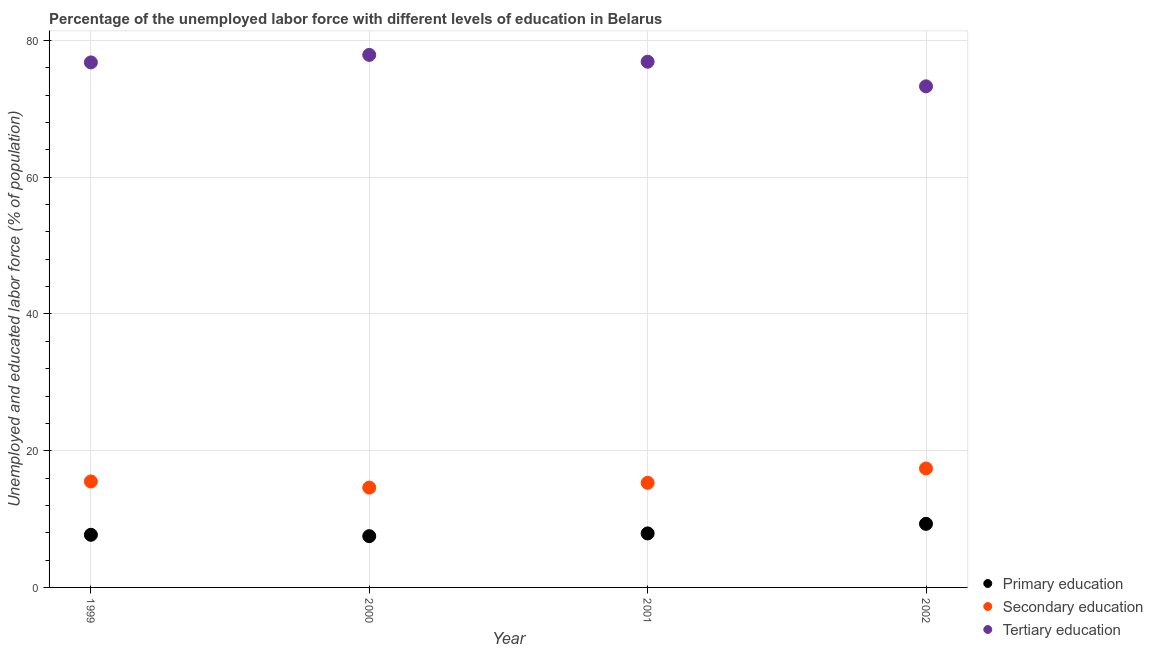Is the number of dotlines equal to the number of legend labels?
Offer a very short reply. Yes. What is the percentage of labor force who received primary education in 1999?
Give a very brief answer. 7.7. Across all years, what is the maximum percentage of labor force who received secondary education?
Keep it short and to the point. 17.4. Across all years, what is the minimum percentage of labor force who received tertiary education?
Keep it short and to the point. 73.3. In which year was the percentage of labor force who received primary education maximum?
Make the answer very short. 2002. In which year was the percentage of labor force who received secondary education minimum?
Provide a succinct answer. 2000. What is the total percentage of labor force who received tertiary education in the graph?
Ensure brevity in your answer.  304.9. What is the difference between the percentage of labor force who received primary education in 1999 and the percentage of labor force who received tertiary education in 2002?
Offer a very short reply. -65.6. What is the average percentage of labor force who received primary education per year?
Give a very brief answer. 8.1. In the year 2000, what is the difference between the percentage of labor force who received primary education and percentage of labor force who received tertiary education?
Your answer should be compact. -70.4. What is the ratio of the percentage of labor force who received tertiary education in 1999 to that in 2000?
Provide a short and direct response. 0.99. Is the percentage of labor force who received primary education in 2001 less than that in 2002?
Offer a very short reply. Yes. What is the difference between the highest and the second highest percentage of labor force who received tertiary education?
Your answer should be very brief. 1. What is the difference between the highest and the lowest percentage of labor force who received primary education?
Your answer should be compact. 1.8. In how many years, is the percentage of labor force who received primary education greater than the average percentage of labor force who received primary education taken over all years?
Make the answer very short. 1. What is the difference between two consecutive major ticks on the Y-axis?
Your answer should be very brief. 20. Does the graph contain any zero values?
Keep it short and to the point. No. Does the graph contain grids?
Offer a terse response. Yes. Where does the legend appear in the graph?
Ensure brevity in your answer.  Bottom right. What is the title of the graph?
Ensure brevity in your answer.  Percentage of the unemployed labor force with different levels of education in Belarus. What is the label or title of the Y-axis?
Offer a terse response. Unemployed and educated labor force (% of population). What is the Unemployed and educated labor force (% of population) of Primary education in 1999?
Make the answer very short. 7.7. What is the Unemployed and educated labor force (% of population) of Tertiary education in 1999?
Provide a succinct answer. 76.8. What is the Unemployed and educated labor force (% of population) in Primary education in 2000?
Offer a very short reply. 7.5. What is the Unemployed and educated labor force (% of population) in Secondary education in 2000?
Offer a very short reply. 14.6. What is the Unemployed and educated labor force (% of population) in Tertiary education in 2000?
Make the answer very short. 77.9. What is the Unemployed and educated labor force (% of population) in Primary education in 2001?
Your answer should be very brief. 7.9. What is the Unemployed and educated labor force (% of population) of Secondary education in 2001?
Give a very brief answer. 15.3. What is the Unemployed and educated labor force (% of population) in Tertiary education in 2001?
Give a very brief answer. 76.9. What is the Unemployed and educated labor force (% of population) of Primary education in 2002?
Keep it short and to the point. 9.3. What is the Unemployed and educated labor force (% of population) of Secondary education in 2002?
Ensure brevity in your answer.  17.4. What is the Unemployed and educated labor force (% of population) in Tertiary education in 2002?
Keep it short and to the point. 73.3. Across all years, what is the maximum Unemployed and educated labor force (% of population) in Primary education?
Your answer should be very brief. 9.3. Across all years, what is the maximum Unemployed and educated labor force (% of population) of Secondary education?
Your answer should be compact. 17.4. Across all years, what is the maximum Unemployed and educated labor force (% of population) of Tertiary education?
Provide a short and direct response. 77.9. Across all years, what is the minimum Unemployed and educated labor force (% of population) of Primary education?
Make the answer very short. 7.5. Across all years, what is the minimum Unemployed and educated labor force (% of population) in Secondary education?
Make the answer very short. 14.6. Across all years, what is the minimum Unemployed and educated labor force (% of population) in Tertiary education?
Give a very brief answer. 73.3. What is the total Unemployed and educated labor force (% of population) of Primary education in the graph?
Provide a succinct answer. 32.4. What is the total Unemployed and educated labor force (% of population) of Secondary education in the graph?
Give a very brief answer. 62.8. What is the total Unemployed and educated labor force (% of population) of Tertiary education in the graph?
Make the answer very short. 304.9. What is the difference between the Unemployed and educated labor force (% of population) in Primary education in 1999 and that in 2001?
Provide a short and direct response. -0.2. What is the difference between the Unemployed and educated labor force (% of population) of Secondary education in 1999 and that in 2001?
Ensure brevity in your answer.  0.2. What is the difference between the Unemployed and educated labor force (% of population) of Tertiary education in 1999 and that in 2001?
Offer a very short reply. -0.1. What is the difference between the Unemployed and educated labor force (% of population) in Tertiary education in 1999 and that in 2002?
Your answer should be very brief. 3.5. What is the difference between the Unemployed and educated labor force (% of population) in Primary education in 2000 and that in 2001?
Ensure brevity in your answer.  -0.4. What is the difference between the Unemployed and educated labor force (% of population) in Secondary education in 2000 and that in 2001?
Provide a succinct answer. -0.7. What is the difference between the Unemployed and educated labor force (% of population) of Tertiary education in 2000 and that in 2001?
Ensure brevity in your answer.  1. What is the difference between the Unemployed and educated labor force (% of population) in Secondary education in 2000 and that in 2002?
Your answer should be compact. -2.8. What is the difference between the Unemployed and educated labor force (% of population) in Primary education in 2001 and that in 2002?
Offer a very short reply. -1.4. What is the difference between the Unemployed and educated labor force (% of population) of Primary education in 1999 and the Unemployed and educated labor force (% of population) of Secondary education in 2000?
Make the answer very short. -6.9. What is the difference between the Unemployed and educated labor force (% of population) of Primary education in 1999 and the Unemployed and educated labor force (% of population) of Tertiary education in 2000?
Provide a succinct answer. -70.2. What is the difference between the Unemployed and educated labor force (% of population) of Secondary education in 1999 and the Unemployed and educated labor force (% of population) of Tertiary education in 2000?
Your answer should be very brief. -62.4. What is the difference between the Unemployed and educated labor force (% of population) of Primary education in 1999 and the Unemployed and educated labor force (% of population) of Tertiary education in 2001?
Your answer should be very brief. -69.2. What is the difference between the Unemployed and educated labor force (% of population) in Secondary education in 1999 and the Unemployed and educated labor force (% of population) in Tertiary education in 2001?
Provide a succinct answer. -61.4. What is the difference between the Unemployed and educated labor force (% of population) of Primary education in 1999 and the Unemployed and educated labor force (% of population) of Secondary education in 2002?
Offer a very short reply. -9.7. What is the difference between the Unemployed and educated labor force (% of population) in Primary education in 1999 and the Unemployed and educated labor force (% of population) in Tertiary education in 2002?
Your response must be concise. -65.6. What is the difference between the Unemployed and educated labor force (% of population) in Secondary education in 1999 and the Unemployed and educated labor force (% of population) in Tertiary education in 2002?
Give a very brief answer. -57.8. What is the difference between the Unemployed and educated labor force (% of population) of Primary education in 2000 and the Unemployed and educated labor force (% of population) of Secondary education in 2001?
Keep it short and to the point. -7.8. What is the difference between the Unemployed and educated labor force (% of population) of Primary education in 2000 and the Unemployed and educated labor force (% of population) of Tertiary education in 2001?
Make the answer very short. -69.4. What is the difference between the Unemployed and educated labor force (% of population) of Secondary education in 2000 and the Unemployed and educated labor force (% of population) of Tertiary education in 2001?
Offer a terse response. -62.3. What is the difference between the Unemployed and educated labor force (% of population) of Primary education in 2000 and the Unemployed and educated labor force (% of population) of Tertiary education in 2002?
Your answer should be compact. -65.8. What is the difference between the Unemployed and educated labor force (% of population) in Secondary education in 2000 and the Unemployed and educated labor force (% of population) in Tertiary education in 2002?
Your answer should be compact. -58.7. What is the difference between the Unemployed and educated labor force (% of population) in Primary education in 2001 and the Unemployed and educated labor force (% of population) in Tertiary education in 2002?
Offer a very short reply. -65.4. What is the difference between the Unemployed and educated labor force (% of population) in Secondary education in 2001 and the Unemployed and educated labor force (% of population) in Tertiary education in 2002?
Your response must be concise. -58. What is the average Unemployed and educated labor force (% of population) in Primary education per year?
Keep it short and to the point. 8.1. What is the average Unemployed and educated labor force (% of population) in Tertiary education per year?
Offer a terse response. 76.22. In the year 1999, what is the difference between the Unemployed and educated labor force (% of population) in Primary education and Unemployed and educated labor force (% of population) in Tertiary education?
Your response must be concise. -69.1. In the year 1999, what is the difference between the Unemployed and educated labor force (% of population) of Secondary education and Unemployed and educated labor force (% of population) of Tertiary education?
Provide a succinct answer. -61.3. In the year 2000, what is the difference between the Unemployed and educated labor force (% of population) in Primary education and Unemployed and educated labor force (% of population) in Tertiary education?
Your answer should be compact. -70.4. In the year 2000, what is the difference between the Unemployed and educated labor force (% of population) of Secondary education and Unemployed and educated labor force (% of population) of Tertiary education?
Your answer should be compact. -63.3. In the year 2001, what is the difference between the Unemployed and educated labor force (% of population) of Primary education and Unemployed and educated labor force (% of population) of Tertiary education?
Your response must be concise. -69. In the year 2001, what is the difference between the Unemployed and educated labor force (% of population) of Secondary education and Unemployed and educated labor force (% of population) of Tertiary education?
Make the answer very short. -61.6. In the year 2002, what is the difference between the Unemployed and educated labor force (% of population) of Primary education and Unemployed and educated labor force (% of population) of Secondary education?
Your answer should be very brief. -8.1. In the year 2002, what is the difference between the Unemployed and educated labor force (% of population) of Primary education and Unemployed and educated labor force (% of population) of Tertiary education?
Your answer should be compact. -64. In the year 2002, what is the difference between the Unemployed and educated labor force (% of population) in Secondary education and Unemployed and educated labor force (% of population) in Tertiary education?
Provide a short and direct response. -55.9. What is the ratio of the Unemployed and educated labor force (% of population) of Primary education in 1999 to that in 2000?
Provide a short and direct response. 1.03. What is the ratio of the Unemployed and educated labor force (% of population) in Secondary education in 1999 to that in 2000?
Provide a short and direct response. 1.06. What is the ratio of the Unemployed and educated labor force (% of population) in Tertiary education in 1999 to that in 2000?
Give a very brief answer. 0.99. What is the ratio of the Unemployed and educated labor force (% of population) in Primary education in 1999 to that in 2001?
Your answer should be very brief. 0.97. What is the ratio of the Unemployed and educated labor force (% of population) of Secondary education in 1999 to that in 2001?
Your answer should be very brief. 1.01. What is the ratio of the Unemployed and educated labor force (% of population) of Tertiary education in 1999 to that in 2001?
Your response must be concise. 1. What is the ratio of the Unemployed and educated labor force (% of population) of Primary education in 1999 to that in 2002?
Your answer should be compact. 0.83. What is the ratio of the Unemployed and educated labor force (% of population) in Secondary education in 1999 to that in 2002?
Your response must be concise. 0.89. What is the ratio of the Unemployed and educated labor force (% of population) of Tertiary education in 1999 to that in 2002?
Your response must be concise. 1.05. What is the ratio of the Unemployed and educated labor force (% of population) of Primary education in 2000 to that in 2001?
Your response must be concise. 0.95. What is the ratio of the Unemployed and educated labor force (% of population) of Secondary education in 2000 to that in 2001?
Make the answer very short. 0.95. What is the ratio of the Unemployed and educated labor force (% of population) of Tertiary education in 2000 to that in 2001?
Your answer should be very brief. 1.01. What is the ratio of the Unemployed and educated labor force (% of population) of Primary education in 2000 to that in 2002?
Provide a short and direct response. 0.81. What is the ratio of the Unemployed and educated labor force (% of population) of Secondary education in 2000 to that in 2002?
Offer a very short reply. 0.84. What is the ratio of the Unemployed and educated labor force (% of population) in Tertiary education in 2000 to that in 2002?
Offer a very short reply. 1.06. What is the ratio of the Unemployed and educated labor force (% of population) in Primary education in 2001 to that in 2002?
Your response must be concise. 0.85. What is the ratio of the Unemployed and educated labor force (% of population) in Secondary education in 2001 to that in 2002?
Your answer should be very brief. 0.88. What is the ratio of the Unemployed and educated labor force (% of population) in Tertiary education in 2001 to that in 2002?
Provide a succinct answer. 1.05. What is the difference between the highest and the second highest Unemployed and educated labor force (% of population) of Primary education?
Make the answer very short. 1.4. What is the difference between the highest and the lowest Unemployed and educated labor force (% of population) of Secondary education?
Your response must be concise. 2.8. 